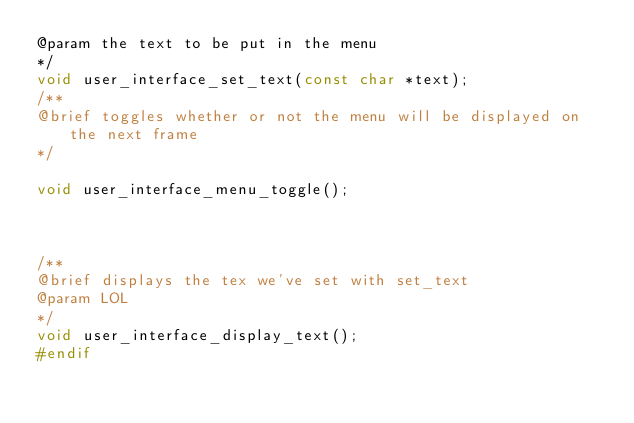<code> <loc_0><loc_0><loc_500><loc_500><_C_>@param the text to be put in the menu
*/
void user_interface_set_text(const char *text);
/**
@brief toggles whether or not the menu will be displayed on the next frame
*/

void user_interface_menu_toggle();



/**
@brief displays the tex we've set with set_text 
@param LOL
*/
void user_interface_display_text();
#endif</code> 